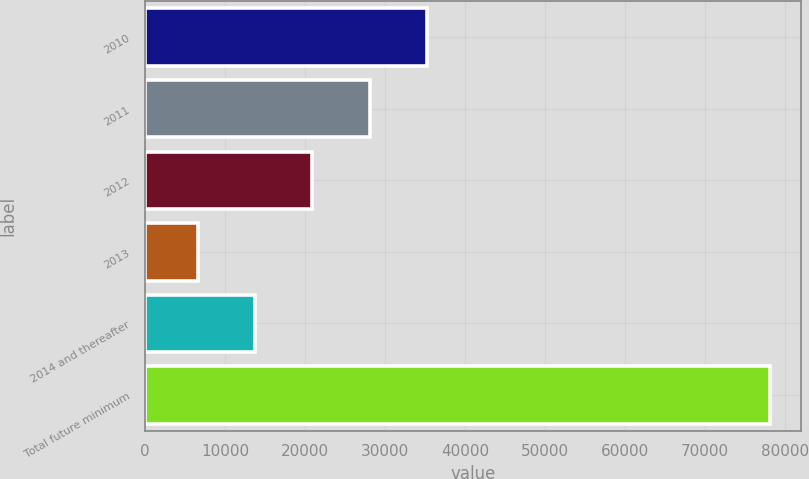Convert chart to OTSL. <chart><loc_0><loc_0><loc_500><loc_500><bar_chart><fcel>2010<fcel>2011<fcel>2012<fcel>2013<fcel>2014 and thereafter<fcel>Total future minimum<nl><fcel>35224.6<fcel>28074.7<fcel>20924.8<fcel>6625<fcel>13774.9<fcel>78124<nl></chart> 